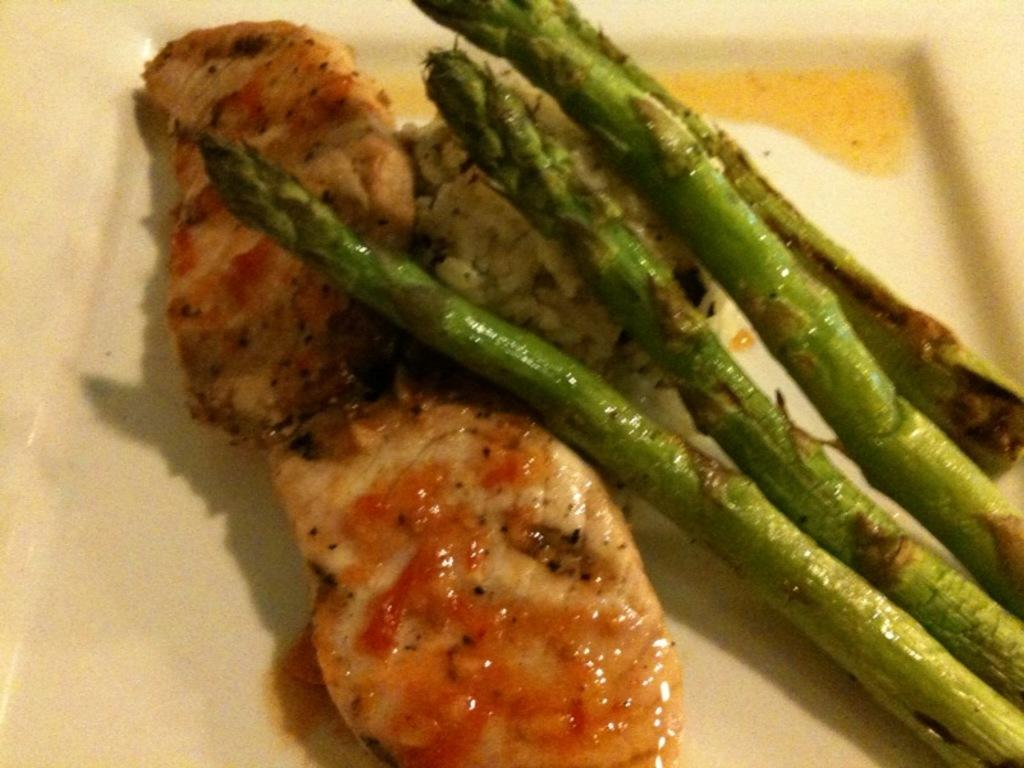What can be seen in the image related to food? There are food items in the image. How are the food items arranged or presented? The food items are placed on a plate. What does the food smell like in the image? The image does not provide information about the smell of the food. 